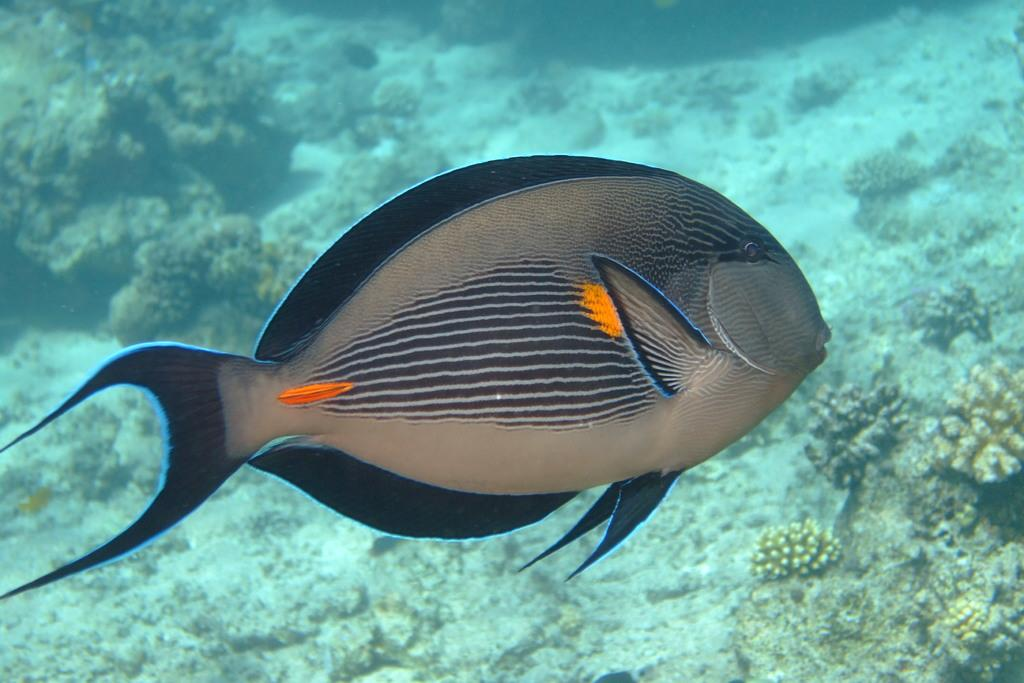What is the main subject of the image? There is a fish in the center of the image. Where is the fish located? The fish is in the water. What can be seen in the background of the image? There is algae in the background of the image. How does the fish express regret in the image? Fish do not have the ability to express regret, as they are not capable of complex emotions like regret. 